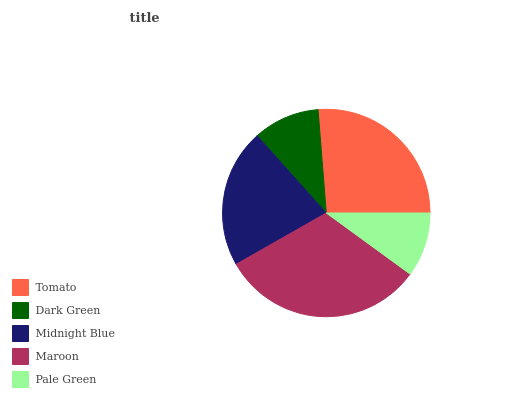Is Pale Green the minimum?
Answer yes or no. Yes. Is Maroon the maximum?
Answer yes or no. Yes. Is Dark Green the minimum?
Answer yes or no. No. Is Dark Green the maximum?
Answer yes or no. No. Is Tomato greater than Dark Green?
Answer yes or no. Yes. Is Dark Green less than Tomato?
Answer yes or no. Yes. Is Dark Green greater than Tomato?
Answer yes or no. No. Is Tomato less than Dark Green?
Answer yes or no. No. Is Midnight Blue the high median?
Answer yes or no. Yes. Is Midnight Blue the low median?
Answer yes or no. Yes. Is Tomato the high median?
Answer yes or no. No. Is Pale Green the low median?
Answer yes or no. No. 